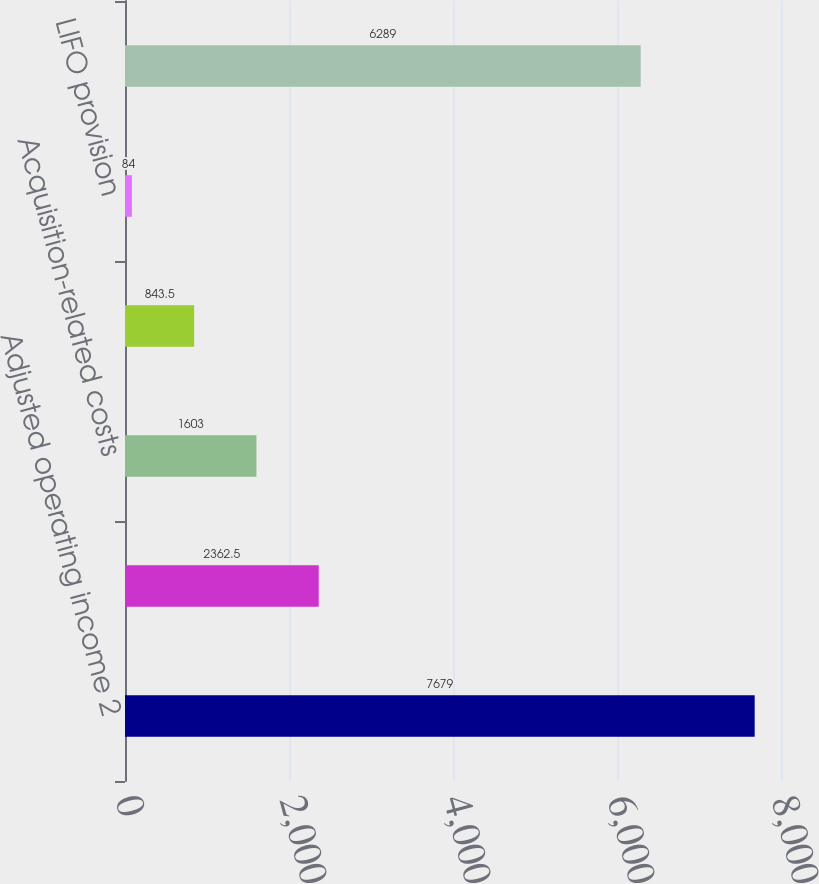Convert chart to OTSL. <chart><loc_0><loc_0><loc_500><loc_500><bar_chart><fcel>Adjusted operating income 2<fcel>Acquisition-related<fcel>Acquisition-related costs<fcel>Adjustments to equity earnings<fcel>LIFO provision<fcel>Operating income 2<nl><fcel>7679<fcel>2362.5<fcel>1603<fcel>843.5<fcel>84<fcel>6289<nl></chart> 